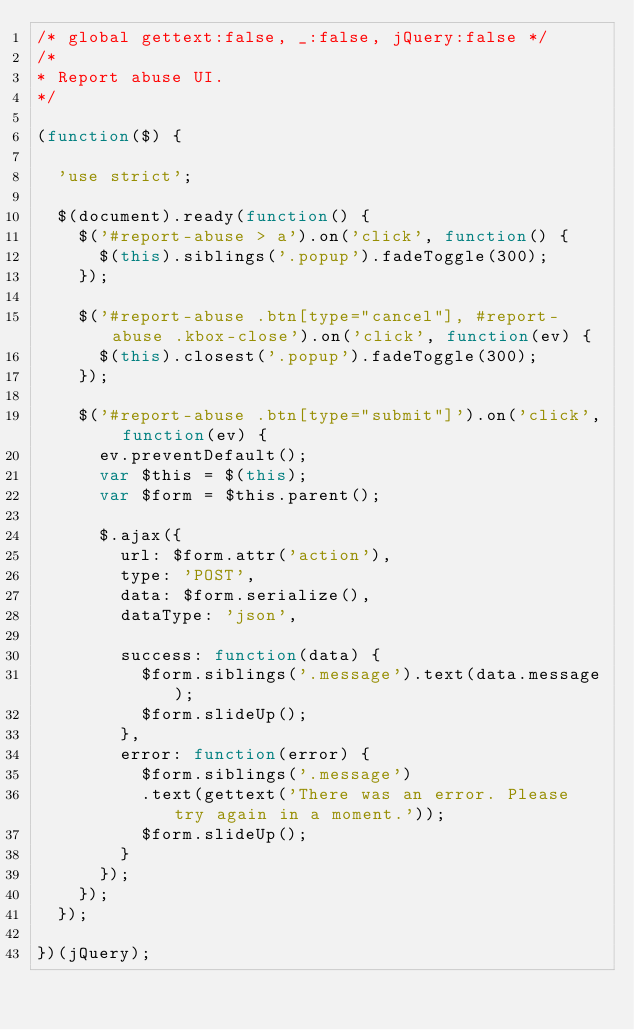Convert code to text. <code><loc_0><loc_0><loc_500><loc_500><_JavaScript_>/* global gettext:false, _:false, jQuery:false */
/*
* Report abuse UI.
*/

(function($) {

  'use strict';

  $(document).ready(function() {
    $('#report-abuse > a').on('click', function() {
      $(this).siblings('.popup').fadeToggle(300);
    });

    $('#report-abuse .btn[type="cancel"], #report-abuse .kbox-close').on('click', function(ev) {
      $(this).closest('.popup').fadeToggle(300);
    });

    $('#report-abuse .btn[type="submit"]').on('click', function(ev) {
      ev.preventDefault();
      var $this = $(this);
      var $form = $this.parent();

      $.ajax({
        url: $form.attr('action'),
        type: 'POST',
        data: $form.serialize(),
        dataType: 'json',

        success: function(data) {
          $form.siblings('.message').text(data.message);
          $form.slideUp();
        },
        error: function(error) {
          $form.siblings('.message')
          .text(gettext('There was an error. Please try again in a moment.'));
          $form.slideUp();
        }
      });
    });
  });

})(jQuery);
</code> 